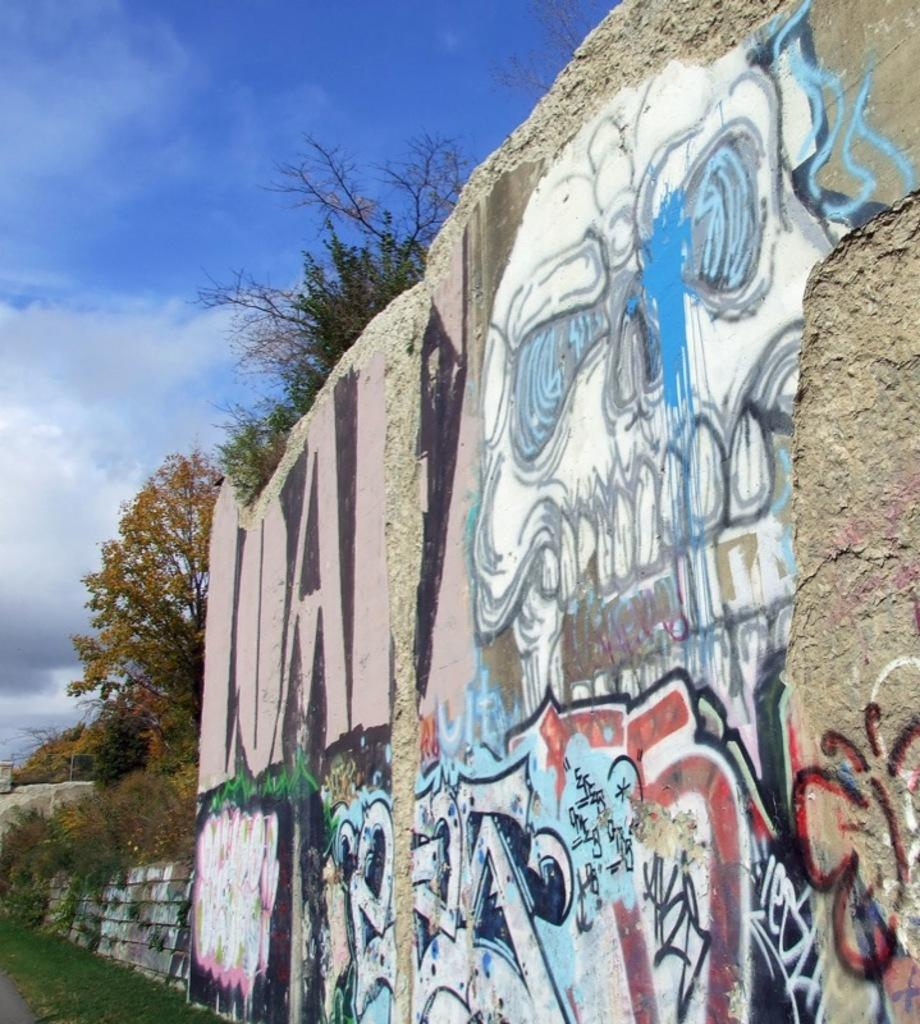Where was the image taken? The image was clicked outside. What can be seen on the right side of the image? There is an art of graffiti on a rock on the right side of the image. What type of vegetation is present on the left side of the image? There is green grass on the left side of the image. What else can be seen on the left side of the image? There are trees present on the left side of the image. What is visible in the background of the image? The sky is visible in the image. What color is the crayon used to draw the graffiti in the image? There is no crayon present in the image; the graffiti is on a rock. How does the graffiti blow away in the image? The graffiti does not blow away in the image; it is a stationary art on the rock. 